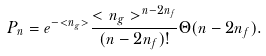<formula> <loc_0><loc_0><loc_500><loc_500>P _ { n } = e ^ { - < n _ { g } > } \frac { < n _ { g } > ^ { n - 2 n _ { f } } } { ( n - 2 n _ { f } ) ! } \Theta ( n - 2 n _ { f } ) .</formula> 